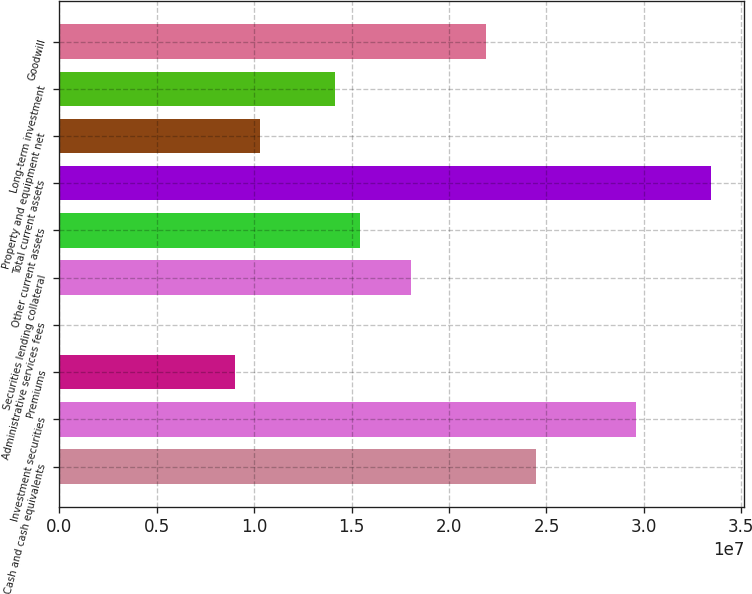Convert chart. <chart><loc_0><loc_0><loc_500><loc_500><bar_chart><fcel>Cash and cash equivalents<fcel>Investment securities<fcel>Premiums<fcel>Administrative services fees<fcel>Securities lending collateral<fcel>Other current assets<fcel>Total current assets<fcel>Property and equipment net<fcel>Long-term investment<fcel>Goodwill<nl><fcel>2.44587e+07<fcel>2.96053e+07<fcel>9.01919e+06<fcel>12780<fcel>1.80256e+07<fcel>1.54523e+07<fcel>3.34651e+07<fcel>1.03058e+07<fcel>1.41657e+07<fcel>2.18855e+07<nl></chart> 